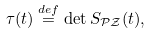Convert formula to latex. <formula><loc_0><loc_0><loc_500><loc_500>\tau ( t ) \stackrel { d e f } { = } \det S _ { \mathcal { P Z } } ( t ) ,</formula> 